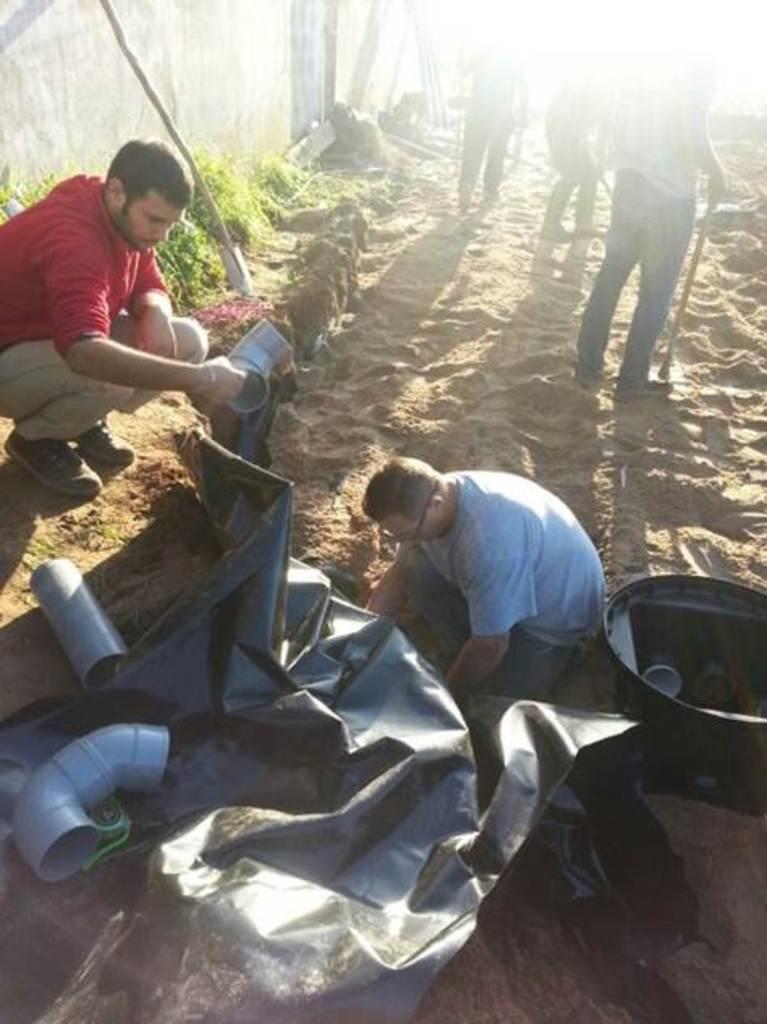Could you give a brief overview of what you see in this image? In this picture we can see the person sitting on the ground and doing plumbing work. In the front there is a black plastic cover. On the left side there is a man wearing the red color t-shirt and holding the plumbing pipe. In the background there is a white wall. 